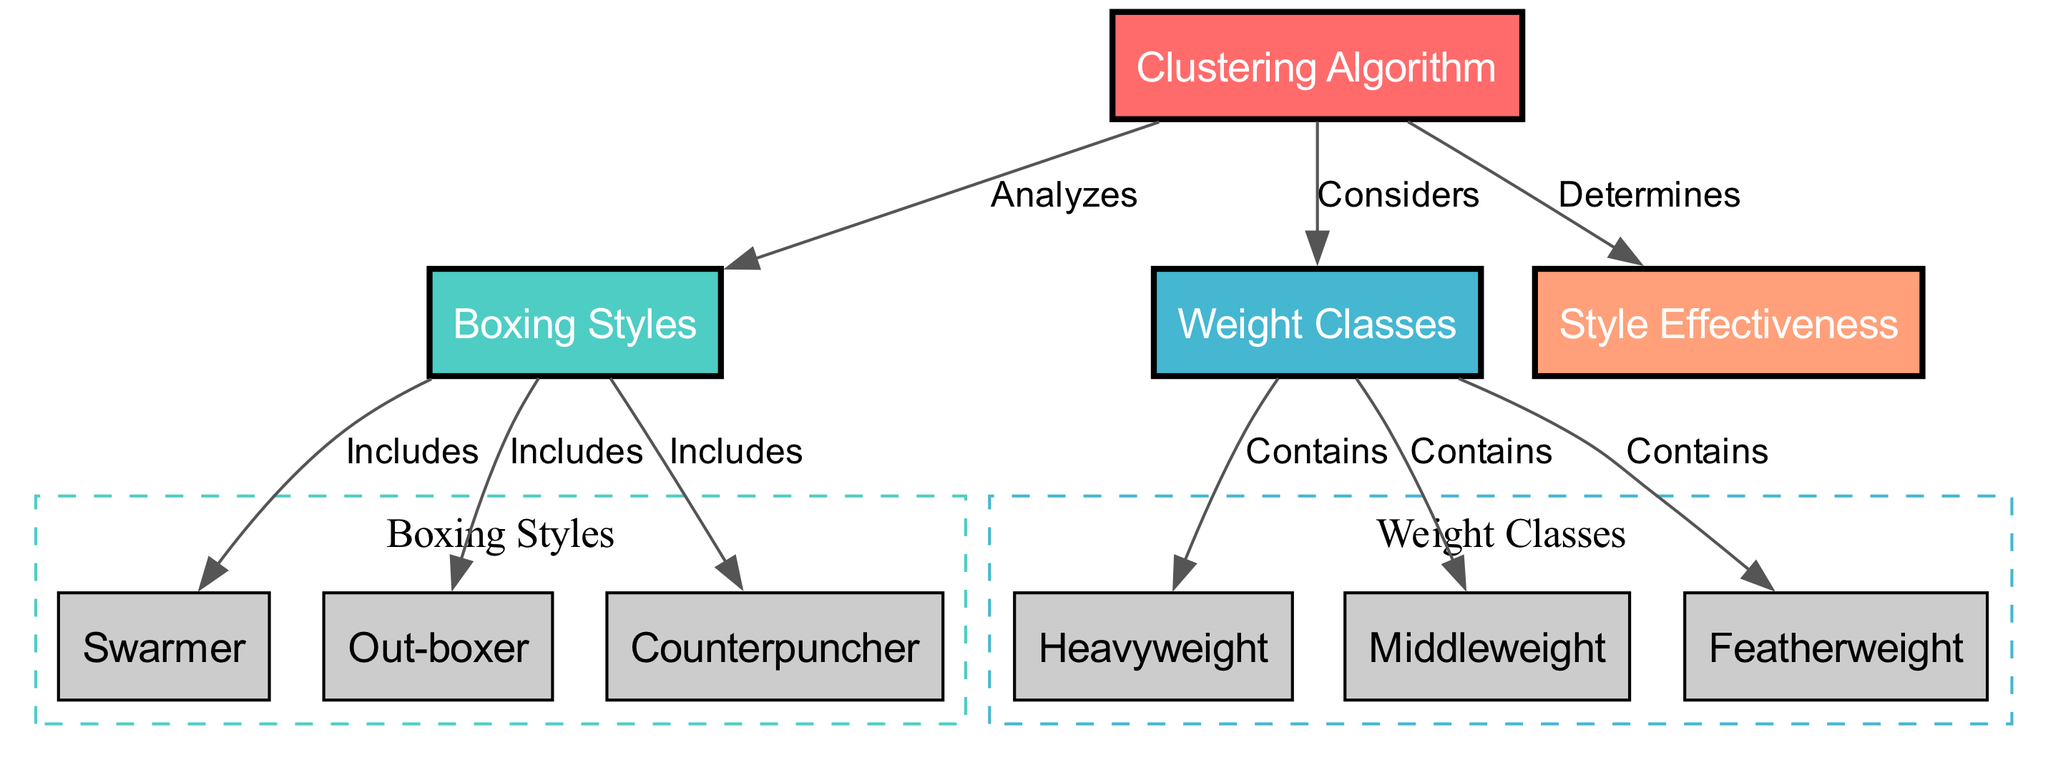What is the main focus of the diagram? The diagram's main focus is the "Clustering Algorithm" which is represented as the central node. This node connects to both "Boxing Styles" and "Weight Classes", indicating its analysis role in the context of different boxing styles and their effectiveness across various weight classes.
Answer: Clustering Algorithm How many boxing styles are included in the diagram? The diagram shows three boxing styles: "Swarmer", "Out-boxer", and "Counterpuncher". They are nodes directly connected to the "Boxing Styles" node. Counting them gives a total of three boxing styles.
Answer: 3 Which node is connected to the "Weight Classes" node? The "Weight Classes" node connects to three specific classes: "Heavyweight", "Middleweight", and "Featherweight", which are directly linked to the same node. Any one of these classes would answer the question accurately.
Answer: Heavyweight What does the "Clustering Algorithm" determine? The "Clustering Algorithm" determines "Style Effectiveness", which indicates its analytical role in evaluating how different boxing styles perform. The connection from the algorithm to this node signifies the output of its analysis.
Answer: Style Effectiveness Which boxing style is categorized as a counterpuncher? The "Counterpuncher" is one of the boxing styles included in the diagram, directly linked to the "Boxing Styles" node. This is a straightforward identification of the style based on its label in the diagram.
Answer: Counterpuncher How many edges lead from the "Boxing Styles" node? The "Boxing Styles" node has three outgoing edges: one each for "Swarmer", "Out-boxer", and "Counterpuncher". By examining the connections visually, we can confirm that three edges are emerging from this node.
Answer: 3 What type of analysis does the diagram depict? The diagram depicts a "clustering" analysis, which is suggested by the central "Clustering Algorithm" node and its connections to boxing styles and weight classes. This terminology reflects the method used to group or categorize similar items.
Answer: Clustering Which weight class has the connection to the "Weight Classes" node? "Heavyweight", "Middleweight", and "Featherweight" are all classes connected to the "Weight Classes" node. Any one of these three classes would be a valid response.
Answer: Heavyweight 